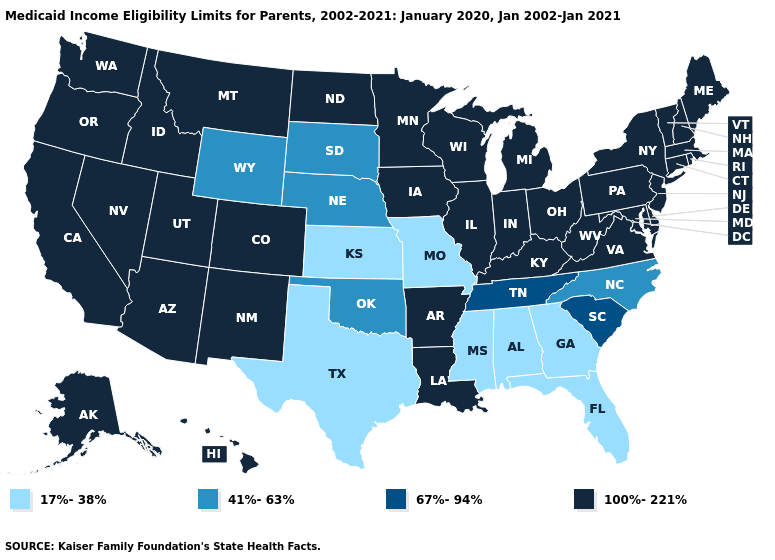Which states hav the highest value in the Northeast?
Give a very brief answer. Connecticut, Maine, Massachusetts, New Hampshire, New Jersey, New York, Pennsylvania, Rhode Island, Vermont. Which states hav the highest value in the South?
Quick response, please. Arkansas, Delaware, Kentucky, Louisiana, Maryland, Virginia, West Virginia. Does Nevada have the highest value in the USA?
Write a very short answer. Yes. Does Mississippi have the highest value in the USA?
Keep it brief. No. Name the states that have a value in the range 100%-221%?
Be succinct. Alaska, Arizona, Arkansas, California, Colorado, Connecticut, Delaware, Hawaii, Idaho, Illinois, Indiana, Iowa, Kentucky, Louisiana, Maine, Maryland, Massachusetts, Michigan, Minnesota, Montana, Nevada, New Hampshire, New Jersey, New Mexico, New York, North Dakota, Ohio, Oregon, Pennsylvania, Rhode Island, Utah, Vermont, Virginia, Washington, West Virginia, Wisconsin. Name the states that have a value in the range 67%-94%?
Write a very short answer. South Carolina, Tennessee. How many symbols are there in the legend?
Quick response, please. 4. Name the states that have a value in the range 17%-38%?
Keep it brief. Alabama, Florida, Georgia, Kansas, Mississippi, Missouri, Texas. Which states have the lowest value in the USA?
Be succinct. Alabama, Florida, Georgia, Kansas, Mississippi, Missouri, Texas. Name the states that have a value in the range 67%-94%?
Give a very brief answer. South Carolina, Tennessee. What is the value of Arkansas?
Short answer required. 100%-221%. Does Iowa have the same value as Mississippi?
Short answer required. No. Which states have the lowest value in the USA?
Answer briefly. Alabama, Florida, Georgia, Kansas, Mississippi, Missouri, Texas. Name the states that have a value in the range 67%-94%?
Concise answer only. South Carolina, Tennessee. Name the states that have a value in the range 17%-38%?
Write a very short answer. Alabama, Florida, Georgia, Kansas, Mississippi, Missouri, Texas. 